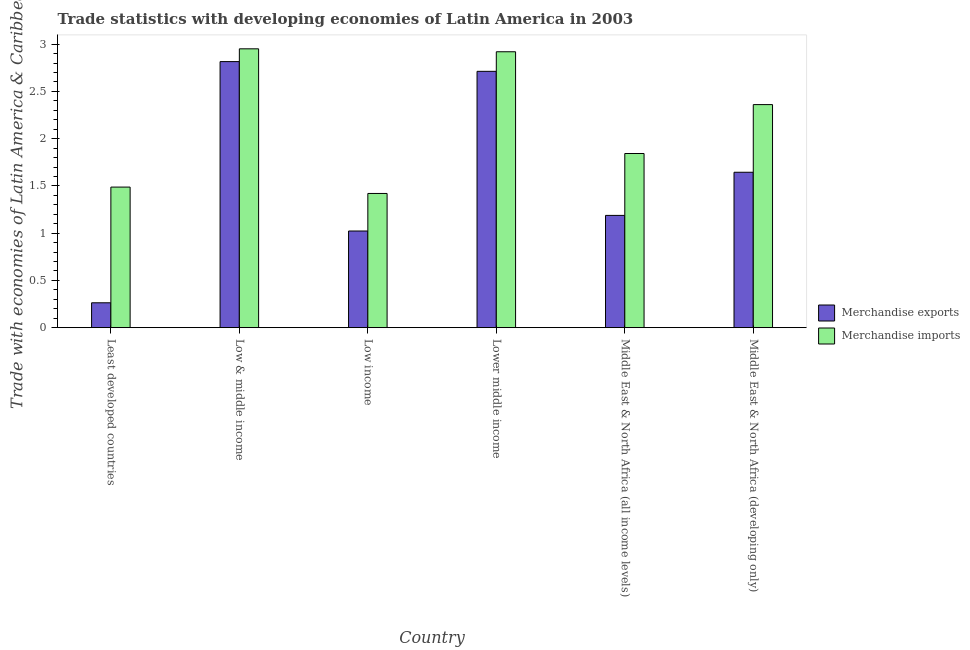How many groups of bars are there?
Ensure brevity in your answer.  6. Are the number of bars per tick equal to the number of legend labels?
Provide a short and direct response. Yes. Are the number of bars on each tick of the X-axis equal?
Make the answer very short. Yes. How many bars are there on the 3rd tick from the right?
Provide a short and direct response. 2. What is the label of the 2nd group of bars from the left?
Your response must be concise. Low & middle income. In how many cases, is the number of bars for a given country not equal to the number of legend labels?
Ensure brevity in your answer.  0. What is the merchandise imports in Lower middle income?
Your response must be concise. 2.92. Across all countries, what is the maximum merchandise imports?
Make the answer very short. 2.95. Across all countries, what is the minimum merchandise imports?
Your answer should be very brief. 1.42. In which country was the merchandise imports minimum?
Make the answer very short. Low income. What is the total merchandise exports in the graph?
Your response must be concise. 9.65. What is the difference between the merchandise imports in Low & middle income and that in Middle East & North Africa (all income levels)?
Provide a short and direct response. 1.11. What is the difference between the merchandise imports in Lower middle income and the merchandise exports in Middle East & North Africa (all income levels)?
Provide a short and direct response. 1.73. What is the average merchandise imports per country?
Make the answer very short. 2.16. What is the difference between the merchandise imports and merchandise exports in Middle East & North Africa (developing only)?
Offer a terse response. 0.72. What is the ratio of the merchandise exports in Low & middle income to that in Lower middle income?
Your answer should be very brief. 1.04. Is the difference between the merchandise imports in Least developed countries and Lower middle income greater than the difference between the merchandise exports in Least developed countries and Lower middle income?
Your response must be concise. Yes. What is the difference between the highest and the second highest merchandise exports?
Provide a succinct answer. 0.1. What is the difference between the highest and the lowest merchandise exports?
Keep it short and to the point. 2.55. Is the sum of the merchandise exports in Low income and Middle East & North Africa (developing only) greater than the maximum merchandise imports across all countries?
Offer a terse response. No. What does the 1st bar from the left in Low & middle income represents?
Your answer should be compact. Merchandise exports. What does the 1st bar from the right in Lower middle income represents?
Ensure brevity in your answer.  Merchandise imports. How many bars are there?
Provide a succinct answer. 12. Does the graph contain any zero values?
Your response must be concise. No. Where does the legend appear in the graph?
Your answer should be very brief. Center right. How many legend labels are there?
Offer a terse response. 2. What is the title of the graph?
Provide a short and direct response. Trade statistics with developing economies of Latin America in 2003. Does "Nitrous oxide emissions" appear as one of the legend labels in the graph?
Give a very brief answer. No. What is the label or title of the X-axis?
Your answer should be compact. Country. What is the label or title of the Y-axis?
Your response must be concise. Trade with economies of Latin America & Caribbean(%). What is the Trade with economies of Latin America & Caribbean(%) of Merchandise exports in Least developed countries?
Keep it short and to the point. 0.26. What is the Trade with economies of Latin America & Caribbean(%) in Merchandise imports in Least developed countries?
Your response must be concise. 1.49. What is the Trade with economies of Latin America & Caribbean(%) in Merchandise exports in Low & middle income?
Ensure brevity in your answer.  2.82. What is the Trade with economies of Latin America & Caribbean(%) in Merchandise imports in Low & middle income?
Provide a short and direct response. 2.95. What is the Trade with economies of Latin America & Caribbean(%) in Merchandise exports in Low income?
Provide a succinct answer. 1.02. What is the Trade with economies of Latin America & Caribbean(%) of Merchandise imports in Low income?
Give a very brief answer. 1.42. What is the Trade with economies of Latin America & Caribbean(%) in Merchandise exports in Lower middle income?
Your answer should be compact. 2.71. What is the Trade with economies of Latin America & Caribbean(%) in Merchandise imports in Lower middle income?
Your answer should be compact. 2.92. What is the Trade with economies of Latin America & Caribbean(%) of Merchandise exports in Middle East & North Africa (all income levels)?
Keep it short and to the point. 1.19. What is the Trade with economies of Latin America & Caribbean(%) of Merchandise imports in Middle East & North Africa (all income levels)?
Offer a terse response. 1.84. What is the Trade with economies of Latin America & Caribbean(%) in Merchandise exports in Middle East & North Africa (developing only)?
Keep it short and to the point. 1.64. What is the Trade with economies of Latin America & Caribbean(%) of Merchandise imports in Middle East & North Africa (developing only)?
Your response must be concise. 2.36. Across all countries, what is the maximum Trade with economies of Latin America & Caribbean(%) in Merchandise exports?
Ensure brevity in your answer.  2.82. Across all countries, what is the maximum Trade with economies of Latin America & Caribbean(%) in Merchandise imports?
Make the answer very short. 2.95. Across all countries, what is the minimum Trade with economies of Latin America & Caribbean(%) of Merchandise exports?
Your answer should be compact. 0.26. Across all countries, what is the minimum Trade with economies of Latin America & Caribbean(%) of Merchandise imports?
Provide a succinct answer. 1.42. What is the total Trade with economies of Latin America & Caribbean(%) of Merchandise exports in the graph?
Your answer should be compact. 9.65. What is the total Trade with economies of Latin America & Caribbean(%) of Merchandise imports in the graph?
Keep it short and to the point. 12.98. What is the difference between the Trade with economies of Latin America & Caribbean(%) of Merchandise exports in Least developed countries and that in Low & middle income?
Your response must be concise. -2.55. What is the difference between the Trade with economies of Latin America & Caribbean(%) of Merchandise imports in Least developed countries and that in Low & middle income?
Keep it short and to the point. -1.46. What is the difference between the Trade with economies of Latin America & Caribbean(%) in Merchandise exports in Least developed countries and that in Low income?
Your answer should be very brief. -0.76. What is the difference between the Trade with economies of Latin America & Caribbean(%) of Merchandise imports in Least developed countries and that in Low income?
Keep it short and to the point. 0.07. What is the difference between the Trade with economies of Latin America & Caribbean(%) of Merchandise exports in Least developed countries and that in Lower middle income?
Make the answer very short. -2.45. What is the difference between the Trade with economies of Latin America & Caribbean(%) of Merchandise imports in Least developed countries and that in Lower middle income?
Give a very brief answer. -1.43. What is the difference between the Trade with economies of Latin America & Caribbean(%) in Merchandise exports in Least developed countries and that in Middle East & North Africa (all income levels)?
Ensure brevity in your answer.  -0.92. What is the difference between the Trade with economies of Latin America & Caribbean(%) of Merchandise imports in Least developed countries and that in Middle East & North Africa (all income levels)?
Your response must be concise. -0.36. What is the difference between the Trade with economies of Latin America & Caribbean(%) of Merchandise exports in Least developed countries and that in Middle East & North Africa (developing only)?
Give a very brief answer. -1.38. What is the difference between the Trade with economies of Latin America & Caribbean(%) of Merchandise imports in Least developed countries and that in Middle East & North Africa (developing only)?
Make the answer very short. -0.87. What is the difference between the Trade with economies of Latin America & Caribbean(%) of Merchandise exports in Low & middle income and that in Low income?
Make the answer very short. 1.79. What is the difference between the Trade with economies of Latin America & Caribbean(%) of Merchandise imports in Low & middle income and that in Low income?
Your response must be concise. 1.53. What is the difference between the Trade with economies of Latin America & Caribbean(%) in Merchandise exports in Low & middle income and that in Lower middle income?
Offer a terse response. 0.1. What is the difference between the Trade with economies of Latin America & Caribbean(%) in Merchandise imports in Low & middle income and that in Lower middle income?
Give a very brief answer. 0.03. What is the difference between the Trade with economies of Latin America & Caribbean(%) in Merchandise exports in Low & middle income and that in Middle East & North Africa (all income levels)?
Make the answer very short. 1.63. What is the difference between the Trade with economies of Latin America & Caribbean(%) in Merchandise imports in Low & middle income and that in Middle East & North Africa (all income levels)?
Provide a succinct answer. 1.11. What is the difference between the Trade with economies of Latin America & Caribbean(%) of Merchandise exports in Low & middle income and that in Middle East & North Africa (developing only)?
Offer a terse response. 1.17. What is the difference between the Trade with economies of Latin America & Caribbean(%) of Merchandise imports in Low & middle income and that in Middle East & North Africa (developing only)?
Your answer should be very brief. 0.59. What is the difference between the Trade with economies of Latin America & Caribbean(%) in Merchandise exports in Low income and that in Lower middle income?
Ensure brevity in your answer.  -1.69. What is the difference between the Trade with economies of Latin America & Caribbean(%) in Merchandise imports in Low income and that in Lower middle income?
Your answer should be compact. -1.5. What is the difference between the Trade with economies of Latin America & Caribbean(%) of Merchandise exports in Low income and that in Middle East & North Africa (all income levels)?
Offer a terse response. -0.17. What is the difference between the Trade with economies of Latin America & Caribbean(%) in Merchandise imports in Low income and that in Middle East & North Africa (all income levels)?
Keep it short and to the point. -0.42. What is the difference between the Trade with economies of Latin America & Caribbean(%) in Merchandise exports in Low income and that in Middle East & North Africa (developing only)?
Ensure brevity in your answer.  -0.62. What is the difference between the Trade with economies of Latin America & Caribbean(%) of Merchandise imports in Low income and that in Middle East & North Africa (developing only)?
Offer a terse response. -0.94. What is the difference between the Trade with economies of Latin America & Caribbean(%) in Merchandise exports in Lower middle income and that in Middle East & North Africa (all income levels)?
Give a very brief answer. 1.52. What is the difference between the Trade with economies of Latin America & Caribbean(%) in Merchandise imports in Lower middle income and that in Middle East & North Africa (all income levels)?
Your answer should be compact. 1.08. What is the difference between the Trade with economies of Latin America & Caribbean(%) in Merchandise exports in Lower middle income and that in Middle East & North Africa (developing only)?
Make the answer very short. 1.07. What is the difference between the Trade with economies of Latin America & Caribbean(%) in Merchandise imports in Lower middle income and that in Middle East & North Africa (developing only)?
Your answer should be very brief. 0.56. What is the difference between the Trade with economies of Latin America & Caribbean(%) in Merchandise exports in Middle East & North Africa (all income levels) and that in Middle East & North Africa (developing only)?
Provide a short and direct response. -0.46. What is the difference between the Trade with economies of Latin America & Caribbean(%) of Merchandise imports in Middle East & North Africa (all income levels) and that in Middle East & North Africa (developing only)?
Your answer should be very brief. -0.52. What is the difference between the Trade with economies of Latin America & Caribbean(%) of Merchandise exports in Least developed countries and the Trade with economies of Latin America & Caribbean(%) of Merchandise imports in Low & middle income?
Offer a terse response. -2.69. What is the difference between the Trade with economies of Latin America & Caribbean(%) in Merchandise exports in Least developed countries and the Trade with economies of Latin America & Caribbean(%) in Merchandise imports in Low income?
Your answer should be very brief. -1.16. What is the difference between the Trade with economies of Latin America & Caribbean(%) in Merchandise exports in Least developed countries and the Trade with economies of Latin America & Caribbean(%) in Merchandise imports in Lower middle income?
Make the answer very short. -2.66. What is the difference between the Trade with economies of Latin America & Caribbean(%) in Merchandise exports in Least developed countries and the Trade with economies of Latin America & Caribbean(%) in Merchandise imports in Middle East & North Africa (all income levels)?
Ensure brevity in your answer.  -1.58. What is the difference between the Trade with economies of Latin America & Caribbean(%) in Merchandise exports in Least developed countries and the Trade with economies of Latin America & Caribbean(%) in Merchandise imports in Middle East & North Africa (developing only)?
Your response must be concise. -2.1. What is the difference between the Trade with economies of Latin America & Caribbean(%) in Merchandise exports in Low & middle income and the Trade with economies of Latin America & Caribbean(%) in Merchandise imports in Low income?
Your answer should be very brief. 1.4. What is the difference between the Trade with economies of Latin America & Caribbean(%) of Merchandise exports in Low & middle income and the Trade with economies of Latin America & Caribbean(%) of Merchandise imports in Lower middle income?
Ensure brevity in your answer.  -0.1. What is the difference between the Trade with economies of Latin America & Caribbean(%) in Merchandise exports in Low & middle income and the Trade with economies of Latin America & Caribbean(%) in Merchandise imports in Middle East & North Africa (all income levels)?
Give a very brief answer. 0.97. What is the difference between the Trade with economies of Latin America & Caribbean(%) in Merchandise exports in Low & middle income and the Trade with economies of Latin America & Caribbean(%) in Merchandise imports in Middle East & North Africa (developing only)?
Your answer should be very brief. 0.46. What is the difference between the Trade with economies of Latin America & Caribbean(%) in Merchandise exports in Low income and the Trade with economies of Latin America & Caribbean(%) in Merchandise imports in Lower middle income?
Offer a terse response. -1.9. What is the difference between the Trade with economies of Latin America & Caribbean(%) of Merchandise exports in Low income and the Trade with economies of Latin America & Caribbean(%) of Merchandise imports in Middle East & North Africa (all income levels)?
Offer a very short reply. -0.82. What is the difference between the Trade with economies of Latin America & Caribbean(%) in Merchandise exports in Low income and the Trade with economies of Latin America & Caribbean(%) in Merchandise imports in Middle East & North Africa (developing only)?
Give a very brief answer. -1.34. What is the difference between the Trade with economies of Latin America & Caribbean(%) in Merchandise exports in Lower middle income and the Trade with economies of Latin America & Caribbean(%) in Merchandise imports in Middle East & North Africa (all income levels)?
Your answer should be compact. 0.87. What is the difference between the Trade with economies of Latin America & Caribbean(%) of Merchandise exports in Lower middle income and the Trade with economies of Latin America & Caribbean(%) of Merchandise imports in Middle East & North Africa (developing only)?
Make the answer very short. 0.35. What is the difference between the Trade with economies of Latin America & Caribbean(%) of Merchandise exports in Middle East & North Africa (all income levels) and the Trade with economies of Latin America & Caribbean(%) of Merchandise imports in Middle East & North Africa (developing only)?
Your response must be concise. -1.17. What is the average Trade with economies of Latin America & Caribbean(%) in Merchandise exports per country?
Provide a succinct answer. 1.61. What is the average Trade with economies of Latin America & Caribbean(%) in Merchandise imports per country?
Your response must be concise. 2.16. What is the difference between the Trade with economies of Latin America & Caribbean(%) in Merchandise exports and Trade with economies of Latin America & Caribbean(%) in Merchandise imports in Least developed countries?
Offer a very short reply. -1.22. What is the difference between the Trade with economies of Latin America & Caribbean(%) in Merchandise exports and Trade with economies of Latin America & Caribbean(%) in Merchandise imports in Low & middle income?
Offer a terse response. -0.14. What is the difference between the Trade with economies of Latin America & Caribbean(%) of Merchandise exports and Trade with economies of Latin America & Caribbean(%) of Merchandise imports in Low income?
Offer a very short reply. -0.4. What is the difference between the Trade with economies of Latin America & Caribbean(%) of Merchandise exports and Trade with economies of Latin America & Caribbean(%) of Merchandise imports in Lower middle income?
Your answer should be compact. -0.21. What is the difference between the Trade with economies of Latin America & Caribbean(%) in Merchandise exports and Trade with economies of Latin America & Caribbean(%) in Merchandise imports in Middle East & North Africa (all income levels)?
Keep it short and to the point. -0.65. What is the difference between the Trade with economies of Latin America & Caribbean(%) of Merchandise exports and Trade with economies of Latin America & Caribbean(%) of Merchandise imports in Middle East & North Africa (developing only)?
Your answer should be compact. -0.72. What is the ratio of the Trade with economies of Latin America & Caribbean(%) of Merchandise exports in Least developed countries to that in Low & middle income?
Your response must be concise. 0.09. What is the ratio of the Trade with economies of Latin America & Caribbean(%) of Merchandise imports in Least developed countries to that in Low & middle income?
Provide a short and direct response. 0.5. What is the ratio of the Trade with economies of Latin America & Caribbean(%) in Merchandise exports in Least developed countries to that in Low income?
Your answer should be very brief. 0.26. What is the ratio of the Trade with economies of Latin America & Caribbean(%) in Merchandise imports in Least developed countries to that in Low income?
Ensure brevity in your answer.  1.05. What is the ratio of the Trade with economies of Latin America & Caribbean(%) of Merchandise exports in Least developed countries to that in Lower middle income?
Provide a succinct answer. 0.1. What is the ratio of the Trade with economies of Latin America & Caribbean(%) of Merchandise imports in Least developed countries to that in Lower middle income?
Make the answer very short. 0.51. What is the ratio of the Trade with economies of Latin America & Caribbean(%) of Merchandise exports in Least developed countries to that in Middle East & North Africa (all income levels)?
Your answer should be compact. 0.22. What is the ratio of the Trade with economies of Latin America & Caribbean(%) in Merchandise imports in Least developed countries to that in Middle East & North Africa (all income levels)?
Offer a very short reply. 0.81. What is the ratio of the Trade with economies of Latin America & Caribbean(%) in Merchandise exports in Least developed countries to that in Middle East & North Africa (developing only)?
Offer a terse response. 0.16. What is the ratio of the Trade with economies of Latin America & Caribbean(%) of Merchandise imports in Least developed countries to that in Middle East & North Africa (developing only)?
Your answer should be very brief. 0.63. What is the ratio of the Trade with economies of Latin America & Caribbean(%) of Merchandise exports in Low & middle income to that in Low income?
Ensure brevity in your answer.  2.75. What is the ratio of the Trade with economies of Latin America & Caribbean(%) of Merchandise imports in Low & middle income to that in Low income?
Ensure brevity in your answer.  2.08. What is the ratio of the Trade with economies of Latin America & Caribbean(%) of Merchandise exports in Low & middle income to that in Lower middle income?
Provide a succinct answer. 1.04. What is the ratio of the Trade with economies of Latin America & Caribbean(%) of Merchandise imports in Low & middle income to that in Lower middle income?
Your answer should be very brief. 1.01. What is the ratio of the Trade with economies of Latin America & Caribbean(%) in Merchandise exports in Low & middle income to that in Middle East & North Africa (all income levels)?
Your response must be concise. 2.37. What is the ratio of the Trade with economies of Latin America & Caribbean(%) of Merchandise imports in Low & middle income to that in Middle East & North Africa (all income levels)?
Keep it short and to the point. 1.6. What is the ratio of the Trade with economies of Latin America & Caribbean(%) of Merchandise exports in Low & middle income to that in Middle East & North Africa (developing only)?
Offer a terse response. 1.71. What is the ratio of the Trade with economies of Latin America & Caribbean(%) of Merchandise imports in Low & middle income to that in Middle East & North Africa (developing only)?
Provide a short and direct response. 1.25. What is the ratio of the Trade with economies of Latin America & Caribbean(%) of Merchandise exports in Low income to that in Lower middle income?
Your response must be concise. 0.38. What is the ratio of the Trade with economies of Latin America & Caribbean(%) of Merchandise imports in Low income to that in Lower middle income?
Your response must be concise. 0.49. What is the ratio of the Trade with economies of Latin America & Caribbean(%) of Merchandise exports in Low income to that in Middle East & North Africa (all income levels)?
Provide a short and direct response. 0.86. What is the ratio of the Trade with economies of Latin America & Caribbean(%) in Merchandise imports in Low income to that in Middle East & North Africa (all income levels)?
Provide a succinct answer. 0.77. What is the ratio of the Trade with economies of Latin America & Caribbean(%) in Merchandise exports in Low income to that in Middle East & North Africa (developing only)?
Provide a short and direct response. 0.62. What is the ratio of the Trade with economies of Latin America & Caribbean(%) of Merchandise imports in Low income to that in Middle East & North Africa (developing only)?
Your response must be concise. 0.6. What is the ratio of the Trade with economies of Latin America & Caribbean(%) of Merchandise exports in Lower middle income to that in Middle East & North Africa (all income levels)?
Offer a terse response. 2.28. What is the ratio of the Trade with economies of Latin America & Caribbean(%) in Merchandise imports in Lower middle income to that in Middle East & North Africa (all income levels)?
Offer a terse response. 1.58. What is the ratio of the Trade with economies of Latin America & Caribbean(%) in Merchandise exports in Lower middle income to that in Middle East & North Africa (developing only)?
Give a very brief answer. 1.65. What is the ratio of the Trade with economies of Latin America & Caribbean(%) in Merchandise imports in Lower middle income to that in Middle East & North Africa (developing only)?
Offer a terse response. 1.24. What is the ratio of the Trade with economies of Latin America & Caribbean(%) of Merchandise exports in Middle East & North Africa (all income levels) to that in Middle East & North Africa (developing only)?
Ensure brevity in your answer.  0.72. What is the ratio of the Trade with economies of Latin America & Caribbean(%) in Merchandise imports in Middle East & North Africa (all income levels) to that in Middle East & North Africa (developing only)?
Offer a very short reply. 0.78. What is the difference between the highest and the second highest Trade with economies of Latin America & Caribbean(%) in Merchandise exports?
Provide a succinct answer. 0.1. What is the difference between the highest and the second highest Trade with economies of Latin America & Caribbean(%) of Merchandise imports?
Your response must be concise. 0.03. What is the difference between the highest and the lowest Trade with economies of Latin America & Caribbean(%) of Merchandise exports?
Offer a terse response. 2.55. What is the difference between the highest and the lowest Trade with economies of Latin America & Caribbean(%) in Merchandise imports?
Ensure brevity in your answer.  1.53. 